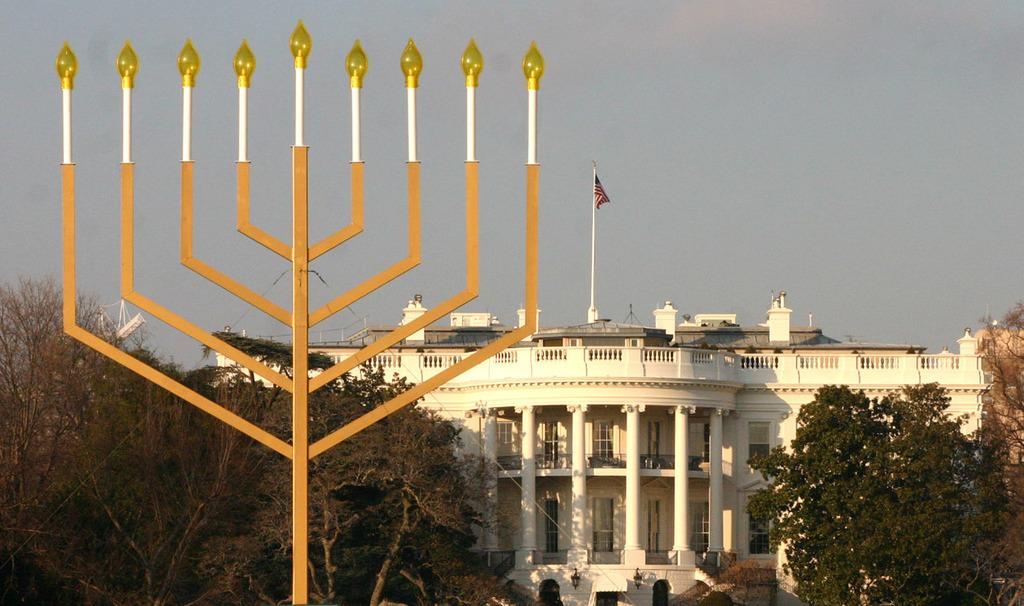What type of structure is present in the image? There is a building in the image. What can be seen in the front of the image? There are lights visible in the front of the image. What type of natural elements are present in the image? There are trees visible in the image. What is visible at the top of the image? The sky is visible at the top of the image. What symbol or emblem is present in the image? There is a flag in the image. How many dogs are visible in the image? There are no dogs present in the image. What type of smoke can be seen coming from the building in the image? There is no smoke visible in the image; it is not mentioned in the provided facts. 